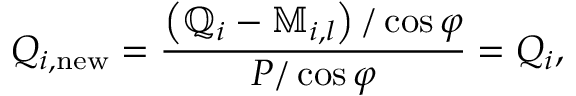Convert formula to latex. <formula><loc_0><loc_0><loc_500><loc_500>Q _ { i , n e w } = \frac { \left ( \mathbb { Q } _ { i } - \mathbb { M } _ { i , l } \right ) / \cos { \varphi } } { P / \cos { \varphi } } = Q _ { i } ,</formula> 